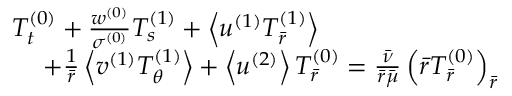<formula> <loc_0><loc_0><loc_500><loc_500>\begin{array} { r } { T _ { t } ^ { ( 0 ) } + \frac { w ^ { ( 0 ) } } { \sigma ^ { ( 0 ) } } T _ { s } ^ { ( 1 ) } + \left < u ^ { ( 1 ) } T _ { \bar { r } } ^ { ( 1 ) } \right > \quad } \\ { + \frac { 1 } { \bar { r } } \left < v ^ { ( 1 ) } T _ { \theta } ^ { ( 1 ) } \right > + \left < u ^ { ( 2 ) } \right > T _ { \bar { r } } ^ { ( 0 ) } = \frac { \bar { \nu } } { \bar { r } \bar { \mu } } \left ( \bar { r } T _ { \bar { r } } ^ { ( 0 ) } \right ) _ { \bar { r } } } \end{array}</formula> 